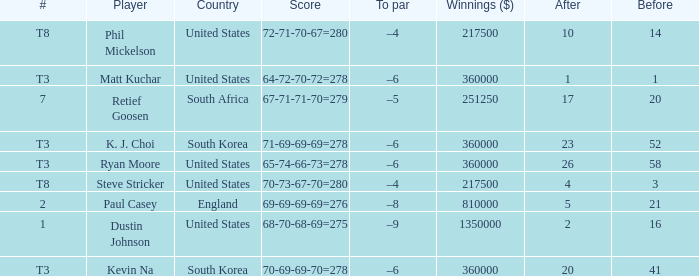How many times is  a to par listed when the player is phil mickelson? 1.0. 